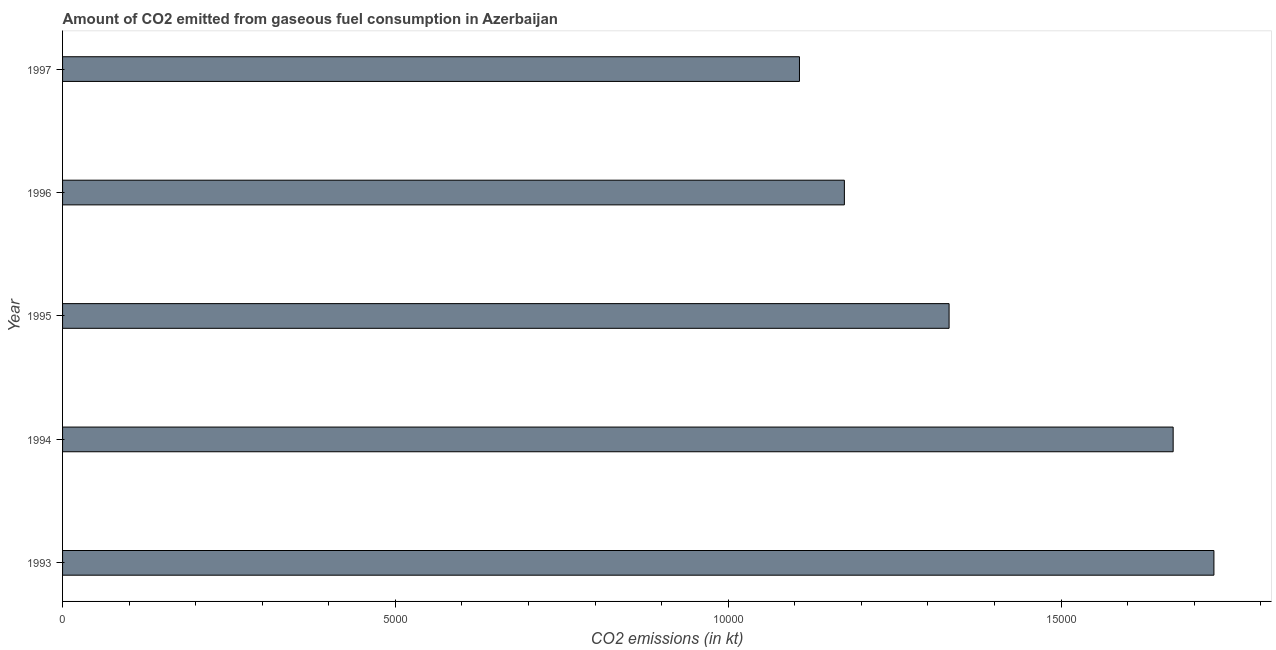What is the title of the graph?
Your answer should be very brief. Amount of CO2 emitted from gaseous fuel consumption in Azerbaijan. What is the label or title of the X-axis?
Ensure brevity in your answer.  CO2 emissions (in kt). What is the label or title of the Y-axis?
Offer a very short reply. Year. What is the co2 emissions from gaseous fuel consumption in 1995?
Give a very brief answer. 1.33e+04. Across all years, what is the maximum co2 emissions from gaseous fuel consumption?
Your answer should be very brief. 1.73e+04. Across all years, what is the minimum co2 emissions from gaseous fuel consumption?
Give a very brief answer. 1.11e+04. In which year was the co2 emissions from gaseous fuel consumption minimum?
Ensure brevity in your answer.  1997. What is the sum of the co2 emissions from gaseous fuel consumption?
Your answer should be very brief. 7.01e+04. What is the difference between the co2 emissions from gaseous fuel consumption in 1994 and 1997?
Ensure brevity in your answer.  5614.18. What is the average co2 emissions from gaseous fuel consumption per year?
Offer a terse response. 1.40e+04. What is the median co2 emissions from gaseous fuel consumption?
Your answer should be very brief. 1.33e+04. In how many years, is the co2 emissions from gaseous fuel consumption greater than 15000 kt?
Your answer should be compact. 2. What is the ratio of the co2 emissions from gaseous fuel consumption in 1995 to that in 1997?
Your answer should be very brief. 1.2. Is the co2 emissions from gaseous fuel consumption in 1994 less than that in 1997?
Offer a terse response. No. Is the difference between the co2 emissions from gaseous fuel consumption in 1994 and 1996 greater than the difference between any two years?
Your answer should be very brief. No. What is the difference between the highest and the second highest co2 emissions from gaseous fuel consumption?
Your answer should be very brief. 612.39. What is the difference between the highest and the lowest co2 emissions from gaseous fuel consumption?
Offer a very short reply. 6226.57. How many bars are there?
Your response must be concise. 5. Are all the bars in the graph horizontal?
Offer a terse response. Yes. What is the difference between two consecutive major ticks on the X-axis?
Your answer should be compact. 5000. Are the values on the major ticks of X-axis written in scientific E-notation?
Your answer should be very brief. No. What is the CO2 emissions (in kt) in 1993?
Make the answer very short. 1.73e+04. What is the CO2 emissions (in kt) in 1994?
Offer a very short reply. 1.67e+04. What is the CO2 emissions (in kt) of 1995?
Your answer should be compact. 1.33e+04. What is the CO2 emissions (in kt) in 1996?
Provide a succinct answer. 1.17e+04. What is the CO2 emissions (in kt) of 1997?
Give a very brief answer. 1.11e+04. What is the difference between the CO2 emissions (in kt) in 1993 and 1994?
Offer a terse response. 612.39. What is the difference between the CO2 emissions (in kt) in 1993 and 1995?
Ensure brevity in your answer.  3978.7. What is the difference between the CO2 emissions (in kt) in 1993 and 1996?
Your answer should be compact. 5551.84. What is the difference between the CO2 emissions (in kt) in 1993 and 1997?
Provide a short and direct response. 6226.57. What is the difference between the CO2 emissions (in kt) in 1994 and 1995?
Keep it short and to the point. 3366.31. What is the difference between the CO2 emissions (in kt) in 1994 and 1996?
Provide a succinct answer. 4939.45. What is the difference between the CO2 emissions (in kt) in 1994 and 1997?
Your answer should be compact. 5614.18. What is the difference between the CO2 emissions (in kt) in 1995 and 1996?
Your answer should be compact. 1573.14. What is the difference between the CO2 emissions (in kt) in 1995 and 1997?
Offer a terse response. 2247.87. What is the difference between the CO2 emissions (in kt) in 1996 and 1997?
Provide a succinct answer. 674.73. What is the ratio of the CO2 emissions (in kt) in 1993 to that in 1995?
Give a very brief answer. 1.3. What is the ratio of the CO2 emissions (in kt) in 1993 to that in 1996?
Your response must be concise. 1.47. What is the ratio of the CO2 emissions (in kt) in 1993 to that in 1997?
Give a very brief answer. 1.56. What is the ratio of the CO2 emissions (in kt) in 1994 to that in 1995?
Offer a terse response. 1.25. What is the ratio of the CO2 emissions (in kt) in 1994 to that in 1996?
Your answer should be very brief. 1.42. What is the ratio of the CO2 emissions (in kt) in 1994 to that in 1997?
Provide a succinct answer. 1.51. What is the ratio of the CO2 emissions (in kt) in 1995 to that in 1996?
Your response must be concise. 1.13. What is the ratio of the CO2 emissions (in kt) in 1995 to that in 1997?
Give a very brief answer. 1.2. What is the ratio of the CO2 emissions (in kt) in 1996 to that in 1997?
Your answer should be compact. 1.06. 